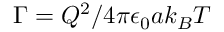<formula> <loc_0><loc_0><loc_500><loc_500>\Gamma = Q ^ { 2 } / 4 \pi \epsilon _ { 0 } a k _ { B } T</formula> 